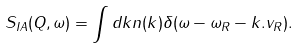<formula> <loc_0><loc_0><loc_500><loc_500>S _ { I A } ( Q , \omega ) = \int d k n ( k ) \delta ( \omega - \omega _ { R } - k . v _ { R } ) .</formula> 